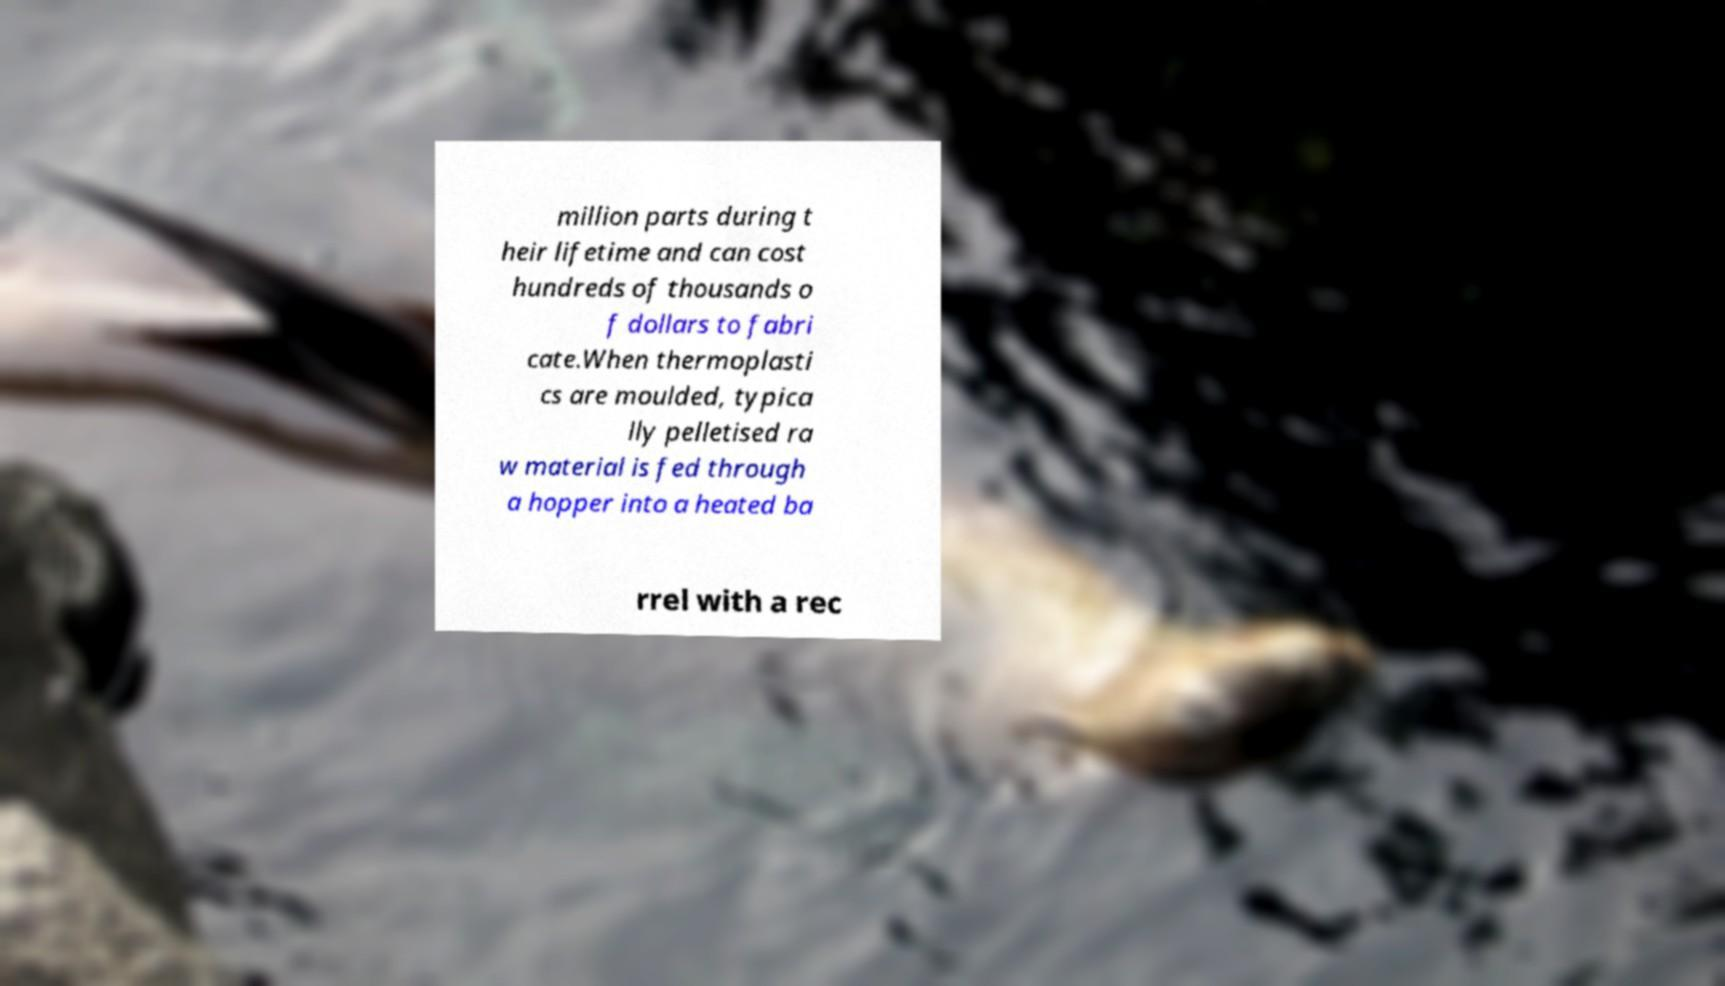Can you accurately transcribe the text from the provided image for me? million parts during t heir lifetime and can cost hundreds of thousands o f dollars to fabri cate.When thermoplasti cs are moulded, typica lly pelletised ra w material is fed through a hopper into a heated ba rrel with a rec 